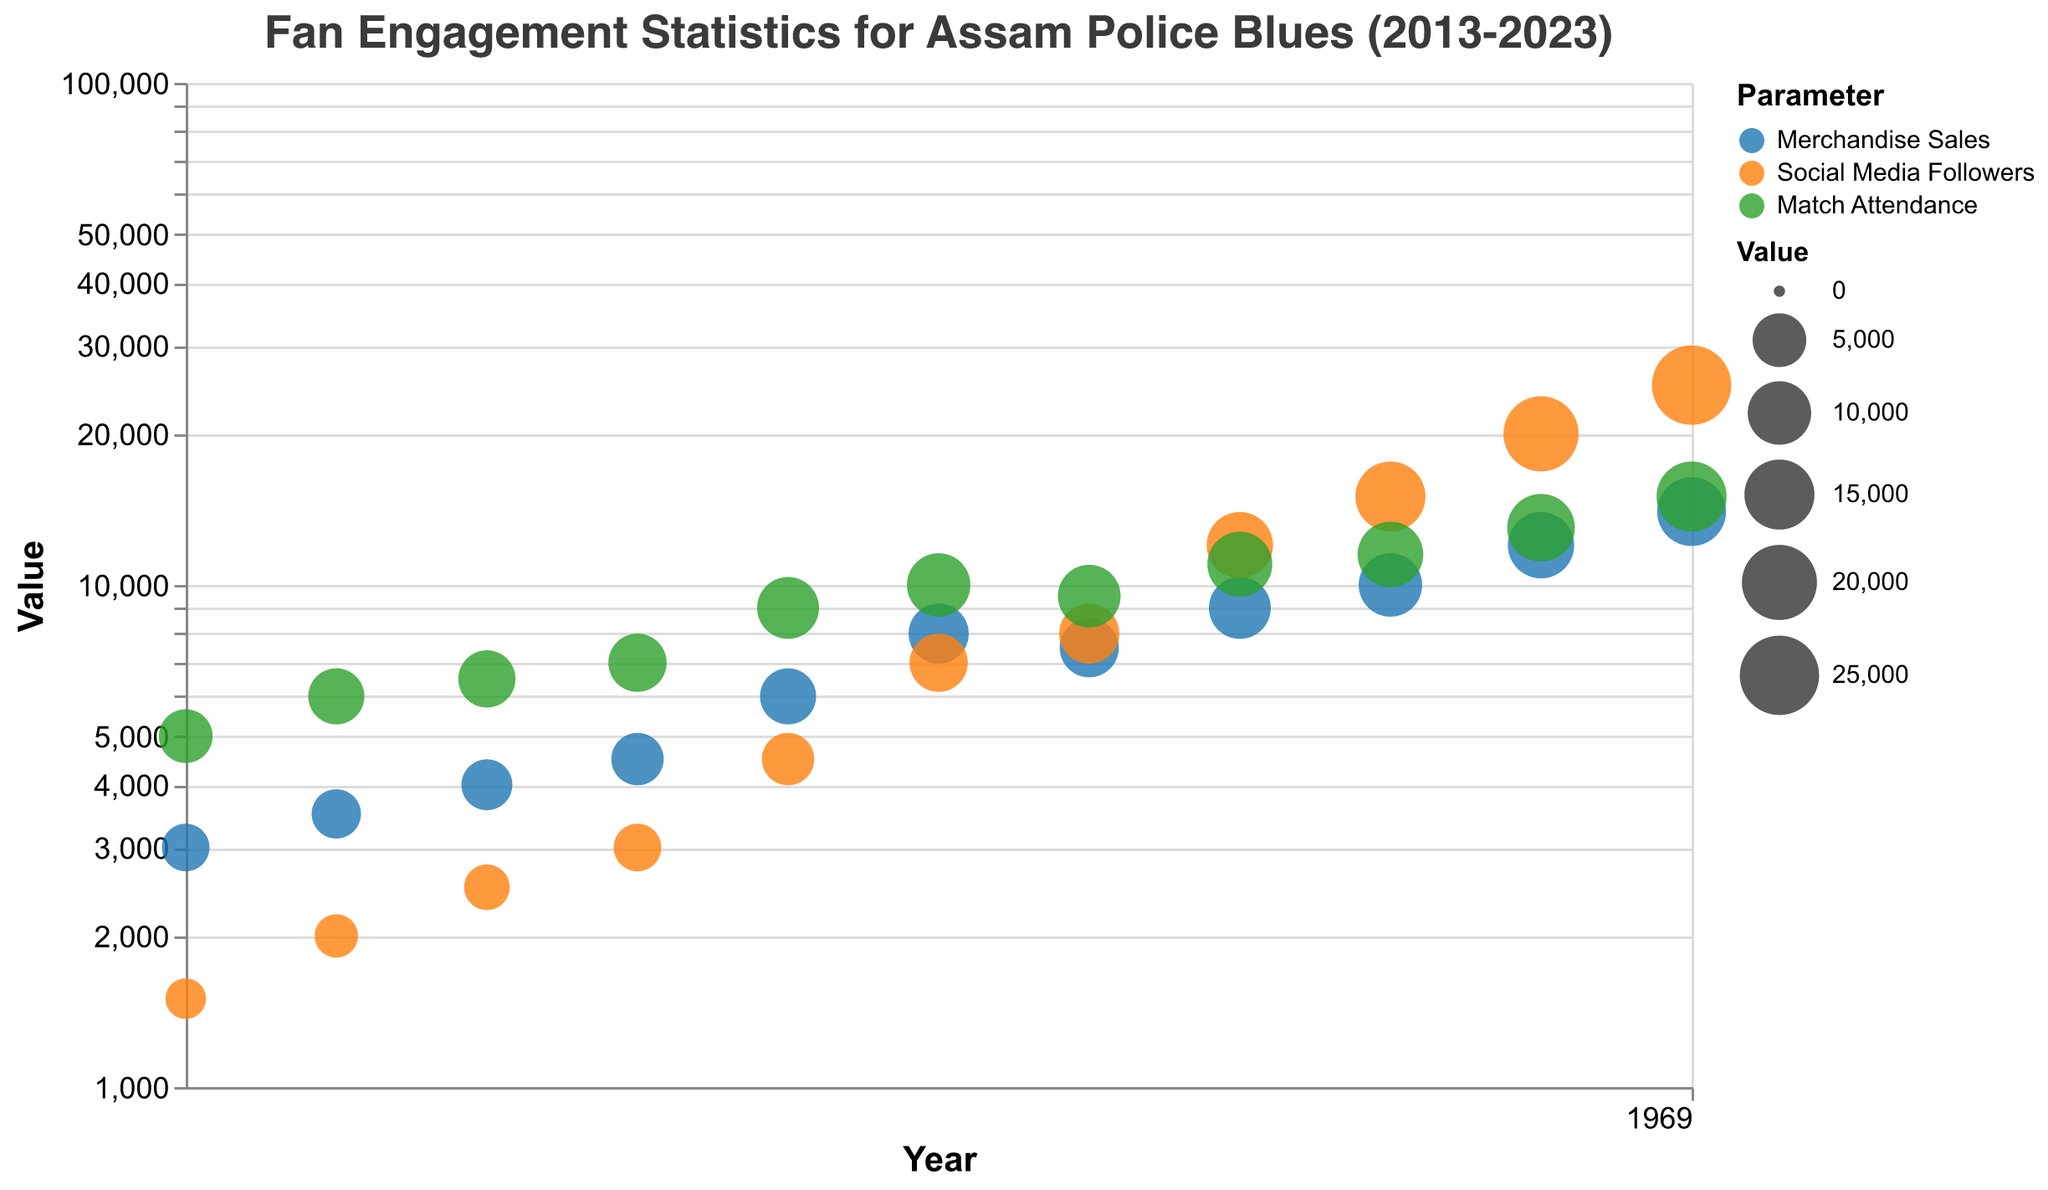How many engagement metrics are visualized for each year? The bubble chart showcases three engagement metrics for each year, represented by different colors: Merchandise Sales, Social Media Followers, and Match Attendance. By counting the different colors per year, we identify three unique metrics.
Answer: Three Which year showed the highest merchandise sales value? Locate the bubble representing Merchandise Sales and look for the one with the highest vertical position or largest size on the y-axis. The year 2023 shows Merchandise Sales at 14,000, the highest on the chart.
Answer: 2023 What is the engagement level for match attendance in 2017? Find the year 2017 and locate the bubble for Match Attendance. The engagement for Match Attendance in 2017 is marked with "High" according to the bubble's color.
Answer: High Compare the social media followers value between 2016 and 2022. Which year has more? Locate the bubbles for Social Media Followers in 2016 and 2022, then compare their positions on the y-axis or sizes. 2022 has a value of 20,000 followers, while 2016 has 3,000, making 2022 the year with more followers.
Answer: 2022 What trend can be observed in the engagement level of Merchandise Sales from 2013 to 2023? Observe the color transitions for Merchandise Sales across the years. Initially, the engagement is low. It increases to medium then high, and finally reaches very high levels from 2022 onwards.
Answer: Increasing In which year did Match Attendance first reach an engagement level of "Very High"? Identify where Match Attendance bubbles transition to the "Very High" level by color. In 2022, the Match Attendance value starts having "Very High" engagement.
Answer: 2022 How does the average value of Social Media Followers change from 2013 to 2023? Calculate the Social Media Followers values for each year: 1,500, 2,000, 2,500, 3,000, 4,500, 7,000, 8,000, 12,000, 15,000, 20,000, 25,000. Sum these values: 100,500. Thus, average over 11 years is 100,500 / 11 ≈ 9,136 followers.
Answer: ~9,136 followers What is the difference in Merchandise Sales between the years 2020 and 2021? Locate the bubble for Merchandise Sales in both 2020 (9,000) and 2021 (10,000) and subtract the earlier year’s value from the latter’s. The difference is 10,000 - 9,000 = 1,000.
Answer: 1,000 Which parameter saw the highest growth in value from 2013 to 2023? Examine changes in values from 2013 to 2023 for each parameter. Merchandise Sales increased from 3,000 to 14,000, Social Media Followers from 1,500 to 25,000, and Match Attendance from 5,000 to 15,000. Social Media Followers saw the highest growth (increase of 23,500).
Answer: Social Media Followers 